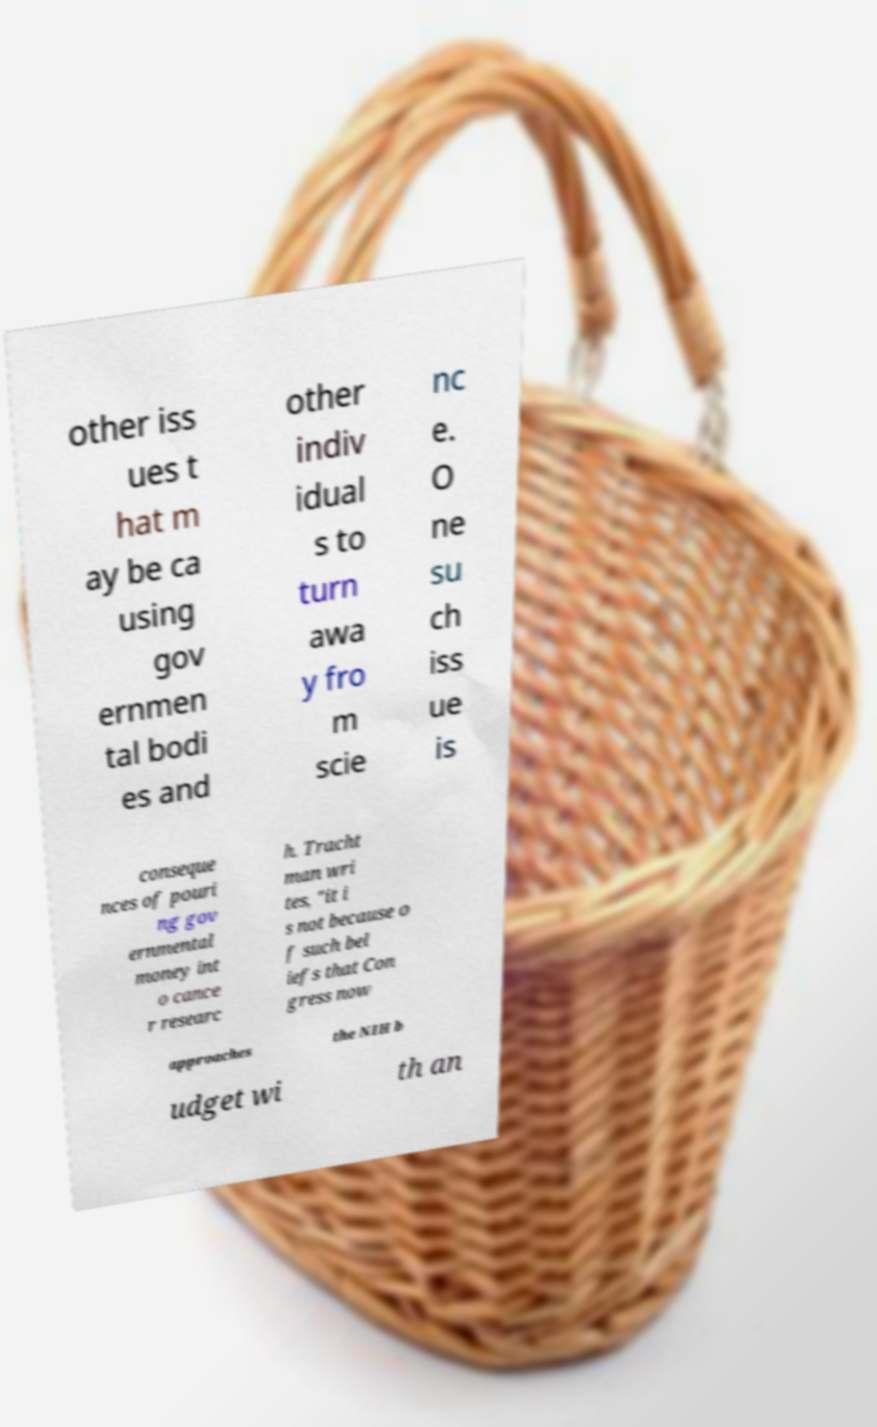For documentation purposes, I need the text within this image transcribed. Could you provide that? other iss ues t hat m ay be ca using gov ernmen tal bodi es and other indiv idual s to turn awa y fro m scie nc e. O ne su ch iss ue is conseque nces of pouri ng gov ernmental money int o cance r researc h. Tracht man wri tes, "it i s not because o f such bel iefs that Con gress now approaches the NIH b udget wi th an 